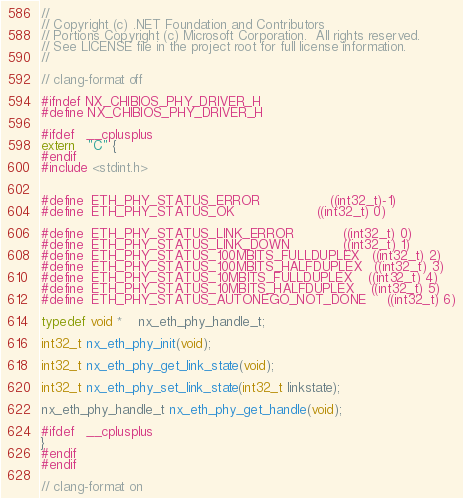<code> <loc_0><loc_0><loc_500><loc_500><_C_>//
// Copyright (c) .NET Foundation and Contributors
// Portions Copyright (c) Microsoft Corporation.  All rights reserved.
// See LICENSE file in the project root for full license information.
//

// clang-format off

#ifndef NX_CHIBIOS_PHY_DRIVER_H
#define NX_CHIBIOS_PHY_DRIVER_H

#ifdef   __cplusplus
extern   "C" {
#endif
#include <stdint.h>


#define  ETH_PHY_STATUS_ERROR                 ((int32_t)-1)
#define  ETH_PHY_STATUS_OK                    ((int32_t) 0)

#define  ETH_PHY_STATUS_LINK_ERROR            ((int32_t) 0)
#define  ETH_PHY_STATUS_LINK_DOWN             ((int32_t) 1)
#define  ETH_PHY_STATUS_100MBITS_FULLDUPLEX   ((int32_t) 2)
#define  ETH_PHY_STATUS_100MBITS_HALFDUPLEX   ((int32_t) 3)
#define  ETH_PHY_STATUS_10MBITS_FULLDUPLEX    ((int32_t) 4)
#define  ETH_PHY_STATUS_10MBITS_HALFDUPLEX    ((int32_t) 5)
#define  ETH_PHY_STATUS_AUTONEGO_NOT_DONE     ((int32_t) 6)

typedef void * 	nx_eth_phy_handle_t;

int32_t nx_eth_phy_init(void);

int32_t nx_eth_phy_get_link_state(void);

int32_t nx_eth_phy_set_link_state(int32_t linkstate);

nx_eth_phy_handle_t nx_eth_phy_get_handle(void);

#ifdef   __cplusplus
}
#endif
#endif

// clang-format on
</code> 